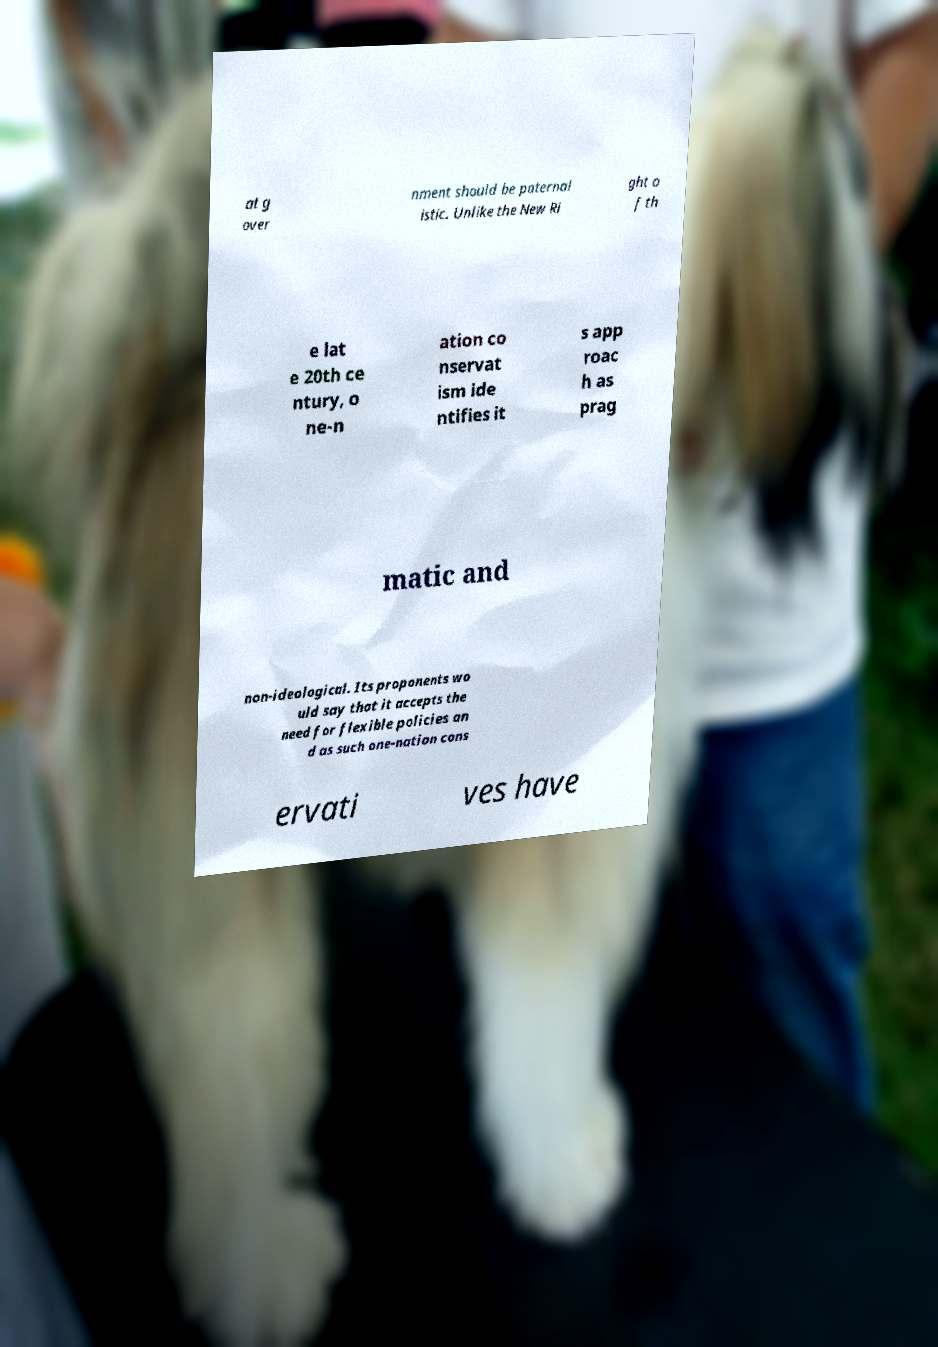Please identify and transcribe the text found in this image. at g over nment should be paternal istic. Unlike the New Ri ght o f th e lat e 20th ce ntury, o ne-n ation co nservat ism ide ntifies it s app roac h as prag matic and non-ideological. Its proponents wo uld say that it accepts the need for flexible policies an d as such one-nation cons ervati ves have 